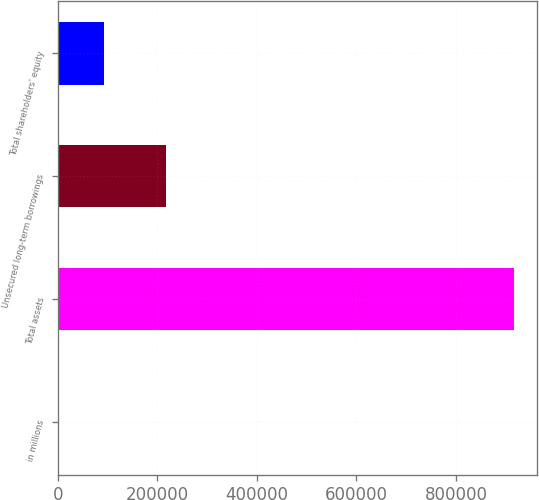<chart> <loc_0><loc_0><loc_500><loc_500><bar_chart><fcel>in millions<fcel>Total assets<fcel>Unsecured long-term borrowings<fcel>Total shareholders' equity<nl><fcel>2017<fcel>916776<fcel>217687<fcel>93492.9<nl></chart> 